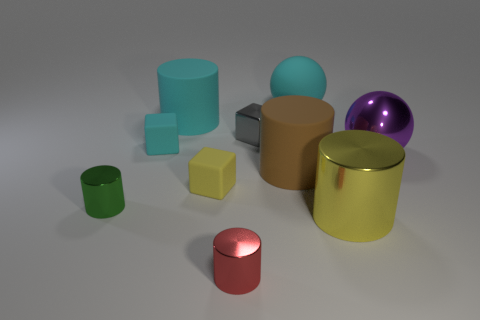Could you describe the lighting and shadow direction in the scene? The lighting in the scene suggests a light source coming from the upper left, as indicated by the shadows that stretch towards the bottom right of each object, creating a consistent perspective of light and shadow across the scene. 